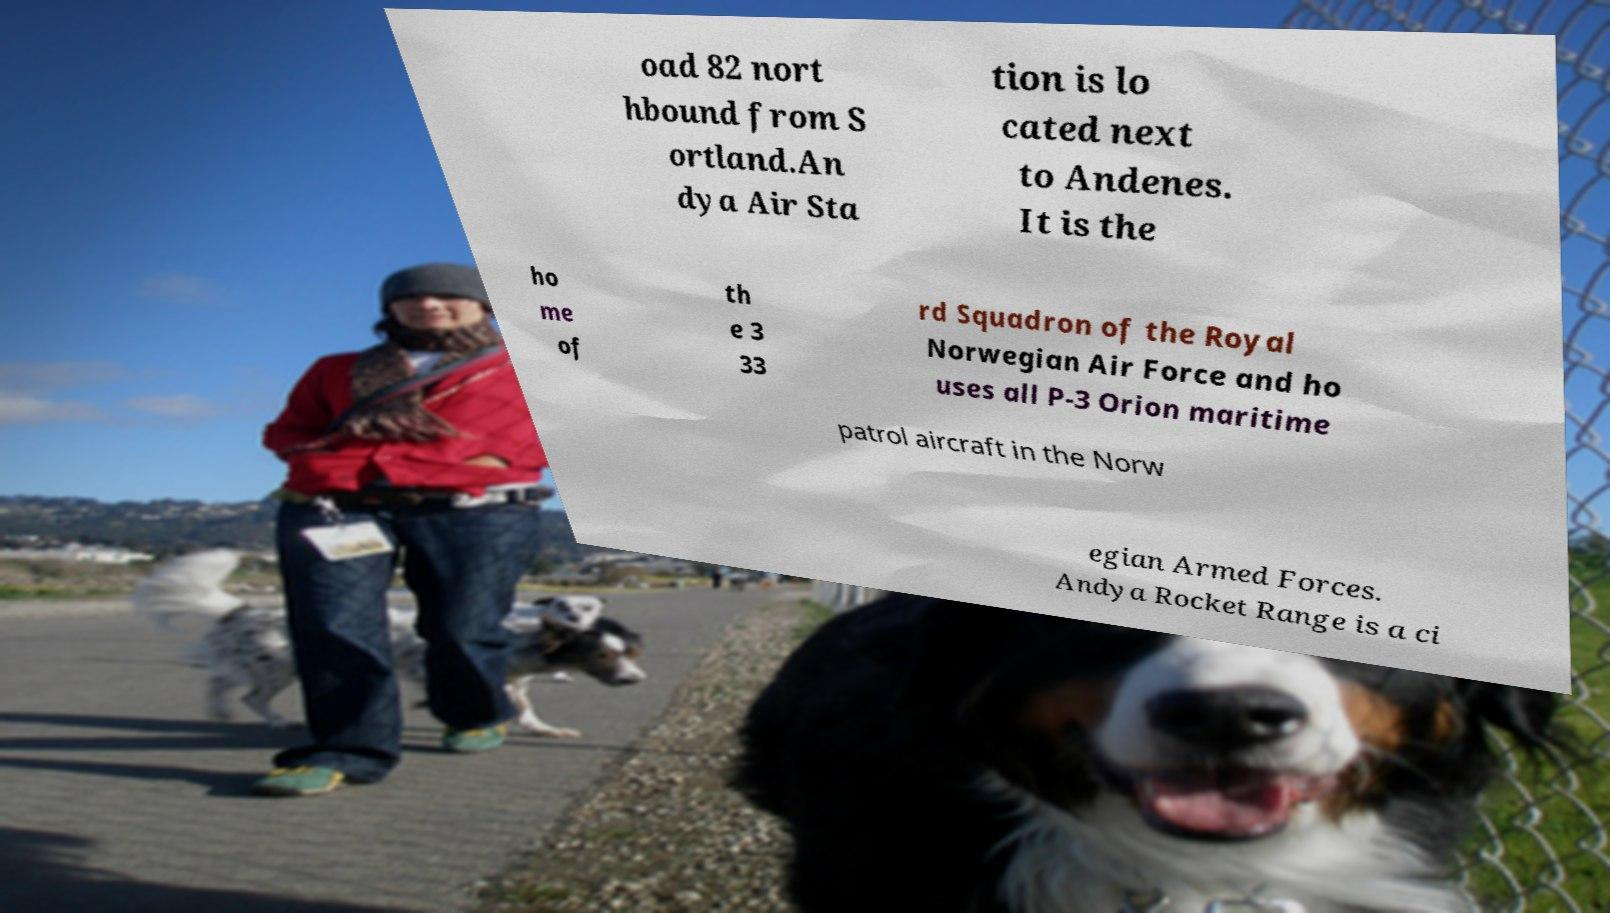For documentation purposes, I need the text within this image transcribed. Could you provide that? oad 82 nort hbound from S ortland.An dya Air Sta tion is lo cated next to Andenes. It is the ho me of th e 3 33 rd Squadron of the Royal Norwegian Air Force and ho uses all P-3 Orion maritime patrol aircraft in the Norw egian Armed Forces. Andya Rocket Range is a ci 